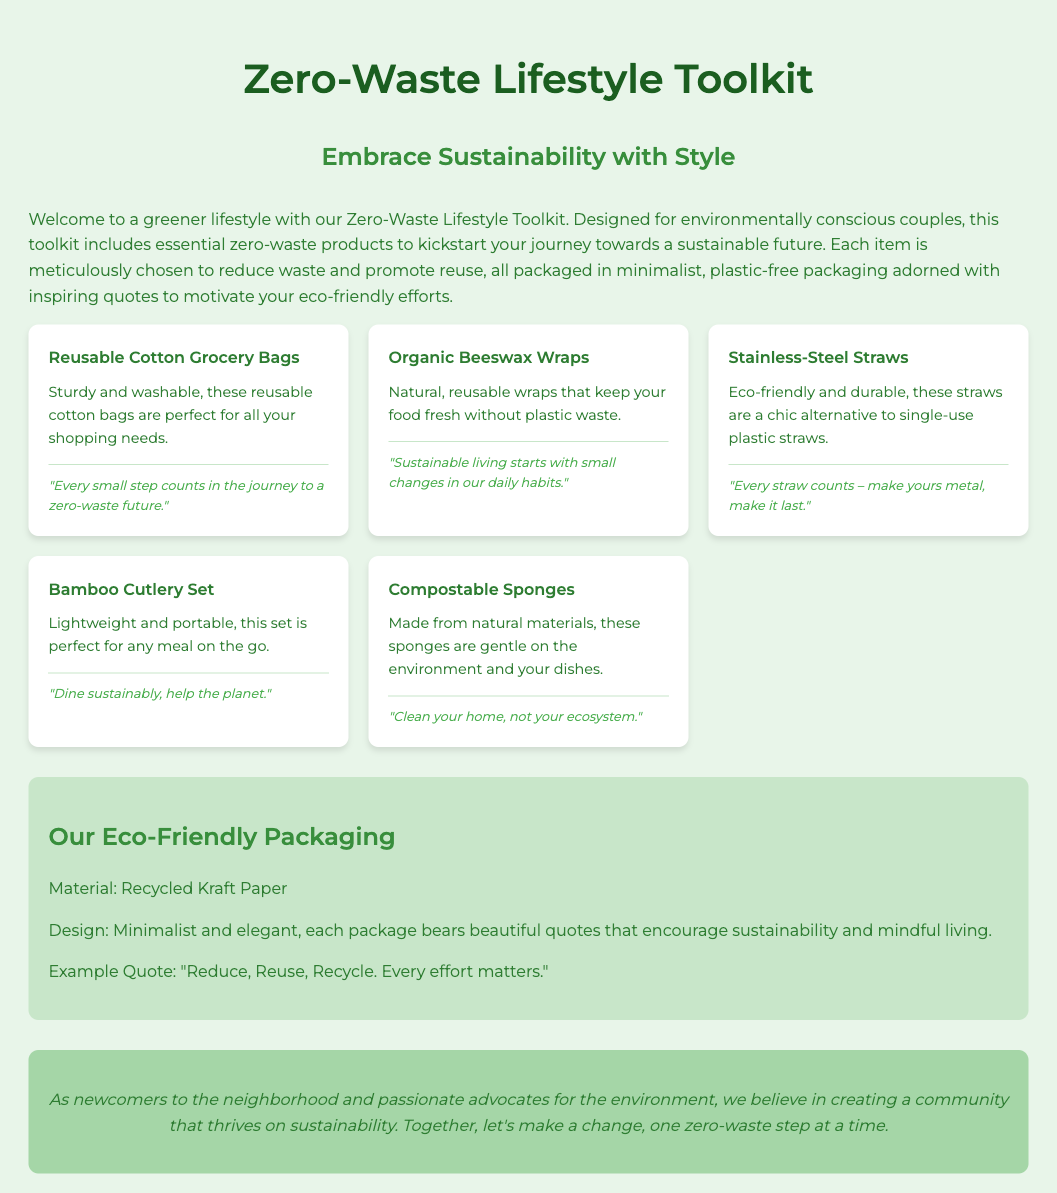What products are included in the toolkit? The toolkit includes several zero-waste products aimed at promoting sustainability.
Answer: Reusable Cotton Grocery Bags, Organic Beeswax Wraps, Stainless-Steel Straws, Bamboo Cutlery Set, Compostable Sponges What is the packaging material used? The packaging is made from recycled materials which enhances its eco-friendliness.
Answer: Recycled Kraft Paper How many product cards are displayed in the document? The number of product cards directly counts the unique items listed in the toolkit.
Answer: Five What quote is featured on the packaging? Specific inspirational quotes included in the design promote sustainability and environmental awareness.
Answer: “Reduce, Reuse, Recycle. Every effort matters.” Who is the target audience for this toolkit? The document defines the audience that the toolkit is designed for based on their values and sustainability efforts.
Answer: Environmentally conscious couples What is the theme of the quotes used in the product descriptions? The quotes featured focus on specific actions and considerations concerning sustainability, urging positive change.
Answer: Reducing waste What is the purpose of the Zero-Waste Lifestyle Toolkit? The toolkit is designed to aid individuals in making environmentally friendly choices in daily life.
Answer: Kickstart your journey towards a sustainable future What is the message from the company? The company expresses a community-oriented environmental message promoting sustainable living.
Answer: Together, let's make a change, one zero-waste step at a time 